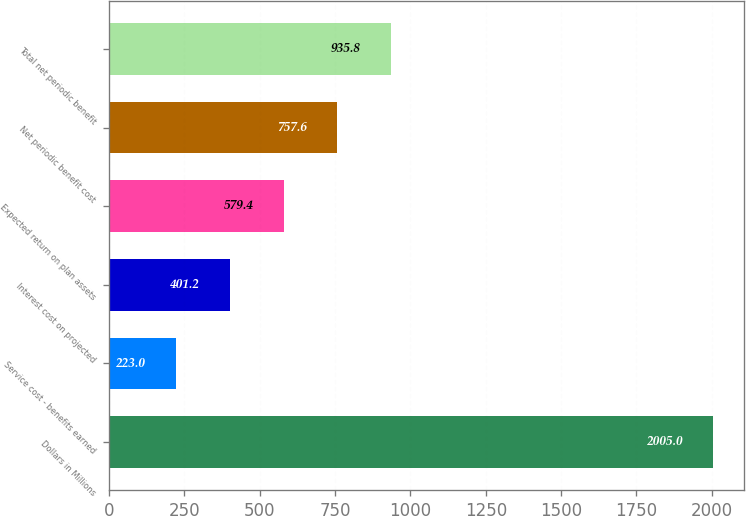<chart> <loc_0><loc_0><loc_500><loc_500><bar_chart><fcel>Dollars in Millions<fcel>Service cost - benefits earned<fcel>Interest cost on projected<fcel>Expected return on plan assets<fcel>Net periodic benefit cost<fcel>Total net periodic benefit<nl><fcel>2005<fcel>223<fcel>401.2<fcel>579.4<fcel>757.6<fcel>935.8<nl></chart> 